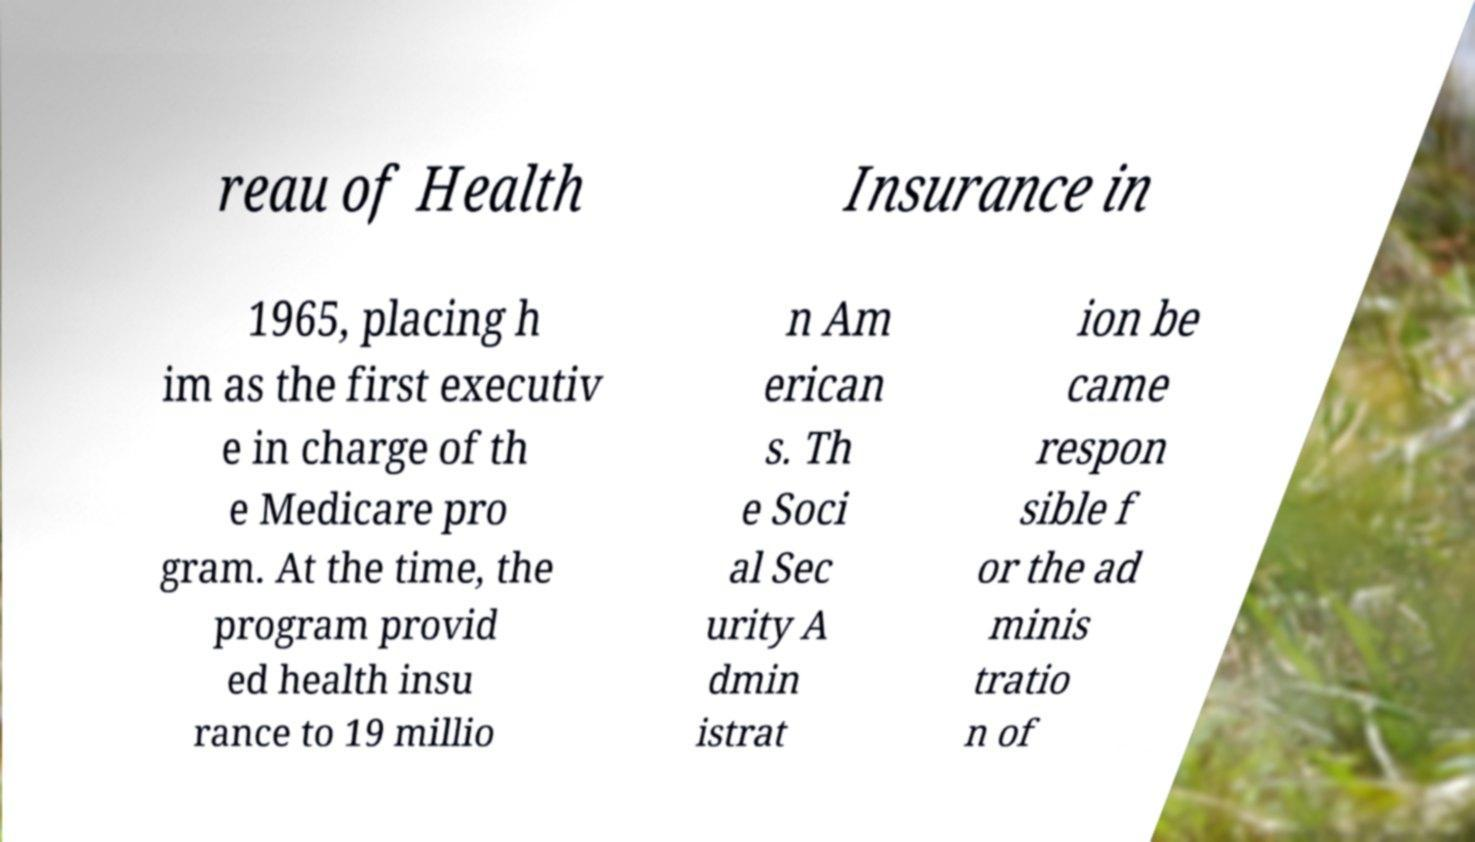What messages or text are displayed in this image? I need them in a readable, typed format. reau of Health Insurance in 1965, placing h im as the first executiv e in charge of th e Medicare pro gram. At the time, the program provid ed health insu rance to 19 millio n Am erican s. Th e Soci al Sec urity A dmin istrat ion be came respon sible f or the ad minis tratio n of 